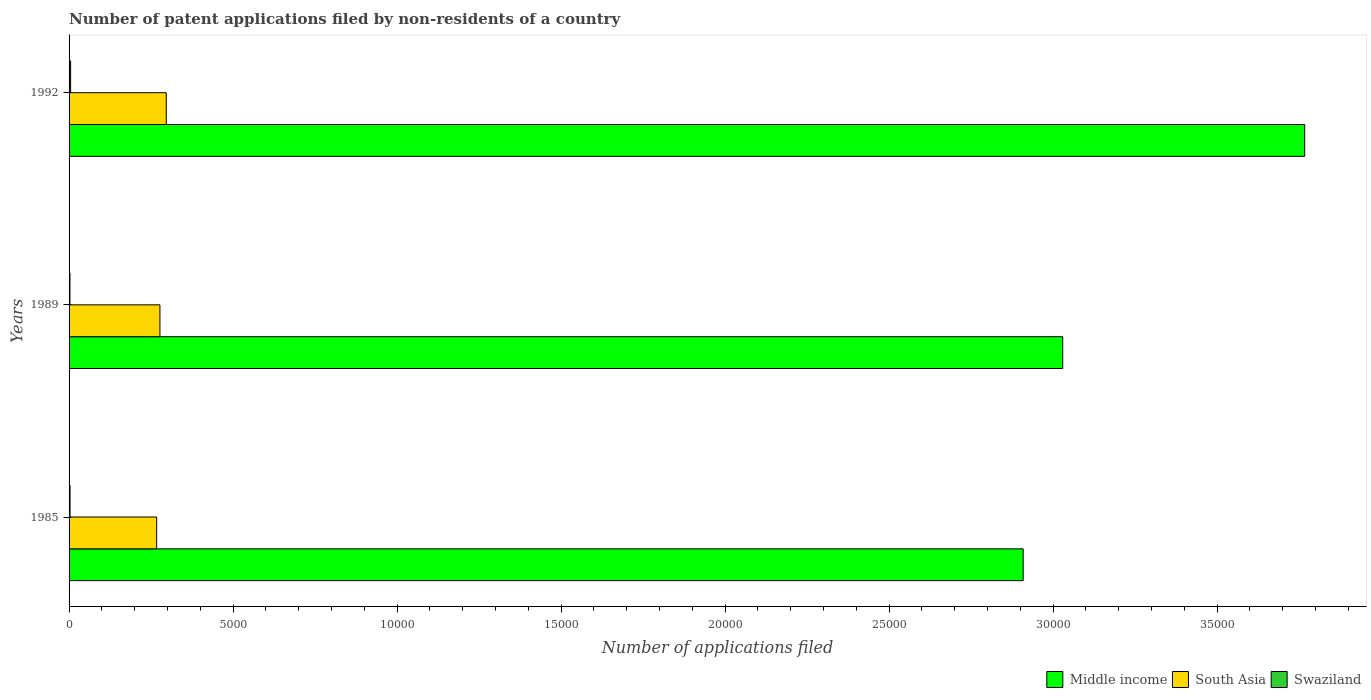How many different coloured bars are there?
Your answer should be very brief. 3. How many groups of bars are there?
Offer a terse response. 3. Are the number of bars per tick equal to the number of legend labels?
Keep it short and to the point. Yes. Are the number of bars on each tick of the Y-axis equal?
Provide a short and direct response. Yes. In how many cases, is the number of bars for a given year not equal to the number of legend labels?
Offer a very short reply. 0. Across all years, what is the maximum number of applications filed in Middle income?
Your answer should be compact. 3.77e+04. In which year was the number of applications filed in Middle income minimum?
Make the answer very short. 1985. What is the total number of applications filed in Swaziland in the graph?
Make the answer very short. 104. What is the difference between the number of applications filed in Middle income in 1992 and the number of applications filed in Swaziland in 1985?
Your answer should be compact. 3.76e+04. What is the average number of applications filed in Middle income per year?
Give a very brief answer. 3.23e+04. In the year 1992, what is the difference between the number of applications filed in South Asia and number of applications filed in Middle income?
Ensure brevity in your answer.  -3.47e+04. What is the ratio of the number of applications filed in Middle income in 1989 to that in 1992?
Your answer should be very brief. 0.8. Is the difference between the number of applications filed in South Asia in 1989 and 1992 greater than the difference between the number of applications filed in Middle income in 1989 and 1992?
Give a very brief answer. Yes. What is the difference between the highest and the second highest number of applications filed in South Asia?
Your answer should be very brief. 193. What is the difference between the highest and the lowest number of applications filed in Middle income?
Your answer should be very brief. 8583. Is the sum of the number of applications filed in Swaziland in 1985 and 1992 greater than the maximum number of applications filed in South Asia across all years?
Your answer should be very brief. No. What does the 2nd bar from the bottom in 1992 represents?
Make the answer very short. South Asia. How many bars are there?
Keep it short and to the point. 9. Are all the bars in the graph horizontal?
Your response must be concise. Yes. How many years are there in the graph?
Your answer should be compact. 3. What is the difference between two consecutive major ticks on the X-axis?
Provide a short and direct response. 5000. Are the values on the major ticks of X-axis written in scientific E-notation?
Offer a very short reply. No. Does the graph contain any zero values?
Provide a succinct answer. No. Does the graph contain grids?
Keep it short and to the point. No. How are the legend labels stacked?
Keep it short and to the point. Horizontal. What is the title of the graph?
Keep it short and to the point. Number of patent applications filed by non-residents of a country. Does "Lower middle income" appear as one of the legend labels in the graph?
Your answer should be compact. No. What is the label or title of the X-axis?
Provide a short and direct response. Number of applications filed. What is the Number of applications filed of Middle income in 1985?
Provide a short and direct response. 2.91e+04. What is the Number of applications filed in South Asia in 1985?
Give a very brief answer. 2670. What is the Number of applications filed of Middle income in 1989?
Offer a terse response. 3.03e+04. What is the Number of applications filed of South Asia in 1989?
Make the answer very short. 2770. What is the Number of applications filed in Swaziland in 1989?
Offer a very short reply. 27. What is the Number of applications filed of Middle income in 1992?
Your response must be concise. 3.77e+04. What is the Number of applications filed in South Asia in 1992?
Offer a terse response. 2963. What is the Number of applications filed in Swaziland in 1992?
Your response must be concise. 47. Across all years, what is the maximum Number of applications filed in Middle income?
Make the answer very short. 3.77e+04. Across all years, what is the maximum Number of applications filed in South Asia?
Keep it short and to the point. 2963. Across all years, what is the minimum Number of applications filed of Middle income?
Offer a terse response. 2.91e+04. Across all years, what is the minimum Number of applications filed in South Asia?
Make the answer very short. 2670. Across all years, what is the minimum Number of applications filed of Swaziland?
Keep it short and to the point. 27. What is the total Number of applications filed of Middle income in the graph?
Make the answer very short. 9.70e+04. What is the total Number of applications filed in South Asia in the graph?
Ensure brevity in your answer.  8403. What is the total Number of applications filed of Swaziland in the graph?
Make the answer very short. 104. What is the difference between the Number of applications filed in Middle income in 1985 and that in 1989?
Offer a very short reply. -1206. What is the difference between the Number of applications filed of South Asia in 1985 and that in 1989?
Keep it short and to the point. -100. What is the difference between the Number of applications filed in Middle income in 1985 and that in 1992?
Your response must be concise. -8583. What is the difference between the Number of applications filed in South Asia in 1985 and that in 1992?
Offer a very short reply. -293. What is the difference between the Number of applications filed of Swaziland in 1985 and that in 1992?
Give a very brief answer. -17. What is the difference between the Number of applications filed of Middle income in 1989 and that in 1992?
Your response must be concise. -7377. What is the difference between the Number of applications filed in South Asia in 1989 and that in 1992?
Your answer should be compact. -193. What is the difference between the Number of applications filed of Swaziland in 1989 and that in 1992?
Keep it short and to the point. -20. What is the difference between the Number of applications filed of Middle income in 1985 and the Number of applications filed of South Asia in 1989?
Provide a succinct answer. 2.63e+04. What is the difference between the Number of applications filed in Middle income in 1985 and the Number of applications filed in Swaziland in 1989?
Make the answer very short. 2.91e+04. What is the difference between the Number of applications filed in South Asia in 1985 and the Number of applications filed in Swaziland in 1989?
Your answer should be compact. 2643. What is the difference between the Number of applications filed in Middle income in 1985 and the Number of applications filed in South Asia in 1992?
Keep it short and to the point. 2.61e+04. What is the difference between the Number of applications filed of Middle income in 1985 and the Number of applications filed of Swaziland in 1992?
Keep it short and to the point. 2.90e+04. What is the difference between the Number of applications filed in South Asia in 1985 and the Number of applications filed in Swaziland in 1992?
Provide a succinct answer. 2623. What is the difference between the Number of applications filed of Middle income in 1989 and the Number of applications filed of South Asia in 1992?
Your response must be concise. 2.73e+04. What is the difference between the Number of applications filed of Middle income in 1989 and the Number of applications filed of Swaziland in 1992?
Your answer should be very brief. 3.02e+04. What is the difference between the Number of applications filed in South Asia in 1989 and the Number of applications filed in Swaziland in 1992?
Provide a succinct answer. 2723. What is the average Number of applications filed in Middle income per year?
Make the answer very short. 3.23e+04. What is the average Number of applications filed in South Asia per year?
Keep it short and to the point. 2801. What is the average Number of applications filed of Swaziland per year?
Offer a very short reply. 34.67. In the year 1985, what is the difference between the Number of applications filed of Middle income and Number of applications filed of South Asia?
Your answer should be very brief. 2.64e+04. In the year 1985, what is the difference between the Number of applications filed in Middle income and Number of applications filed in Swaziland?
Your response must be concise. 2.91e+04. In the year 1985, what is the difference between the Number of applications filed in South Asia and Number of applications filed in Swaziland?
Offer a very short reply. 2640. In the year 1989, what is the difference between the Number of applications filed of Middle income and Number of applications filed of South Asia?
Your response must be concise. 2.75e+04. In the year 1989, what is the difference between the Number of applications filed in Middle income and Number of applications filed in Swaziland?
Provide a succinct answer. 3.03e+04. In the year 1989, what is the difference between the Number of applications filed in South Asia and Number of applications filed in Swaziland?
Your answer should be compact. 2743. In the year 1992, what is the difference between the Number of applications filed of Middle income and Number of applications filed of South Asia?
Offer a terse response. 3.47e+04. In the year 1992, what is the difference between the Number of applications filed in Middle income and Number of applications filed in Swaziland?
Give a very brief answer. 3.76e+04. In the year 1992, what is the difference between the Number of applications filed in South Asia and Number of applications filed in Swaziland?
Make the answer very short. 2916. What is the ratio of the Number of applications filed of Middle income in 1985 to that in 1989?
Give a very brief answer. 0.96. What is the ratio of the Number of applications filed in South Asia in 1985 to that in 1989?
Offer a very short reply. 0.96. What is the ratio of the Number of applications filed of Middle income in 1985 to that in 1992?
Offer a terse response. 0.77. What is the ratio of the Number of applications filed in South Asia in 1985 to that in 1992?
Your answer should be compact. 0.9. What is the ratio of the Number of applications filed in Swaziland in 1985 to that in 1992?
Provide a succinct answer. 0.64. What is the ratio of the Number of applications filed in Middle income in 1989 to that in 1992?
Provide a succinct answer. 0.8. What is the ratio of the Number of applications filed of South Asia in 1989 to that in 1992?
Ensure brevity in your answer.  0.93. What is the ratio of the Number of applications filed in Swaziland in 1989 to that in 1992?
Make the answer very short. 0.57. What is the difference between the highest and the second highest Number of applications filed of Middle income?
Provide a short and direct response. 7377. What is the difference between the highest and the second highest Number of applications filed in South Asia?
Give a very brief answer. 193. What is the difference between the highest and the lowest Number of applications filed in Middle income?
Make the answer very short. 8583. What is the difference between the highest and the lowest Number of applications filed in South Asia?
Make the answer very short. 293. What is the difference between the highest and the lowest Number of applications filed in Swaziland?
Provide a succinct answer. 20. 